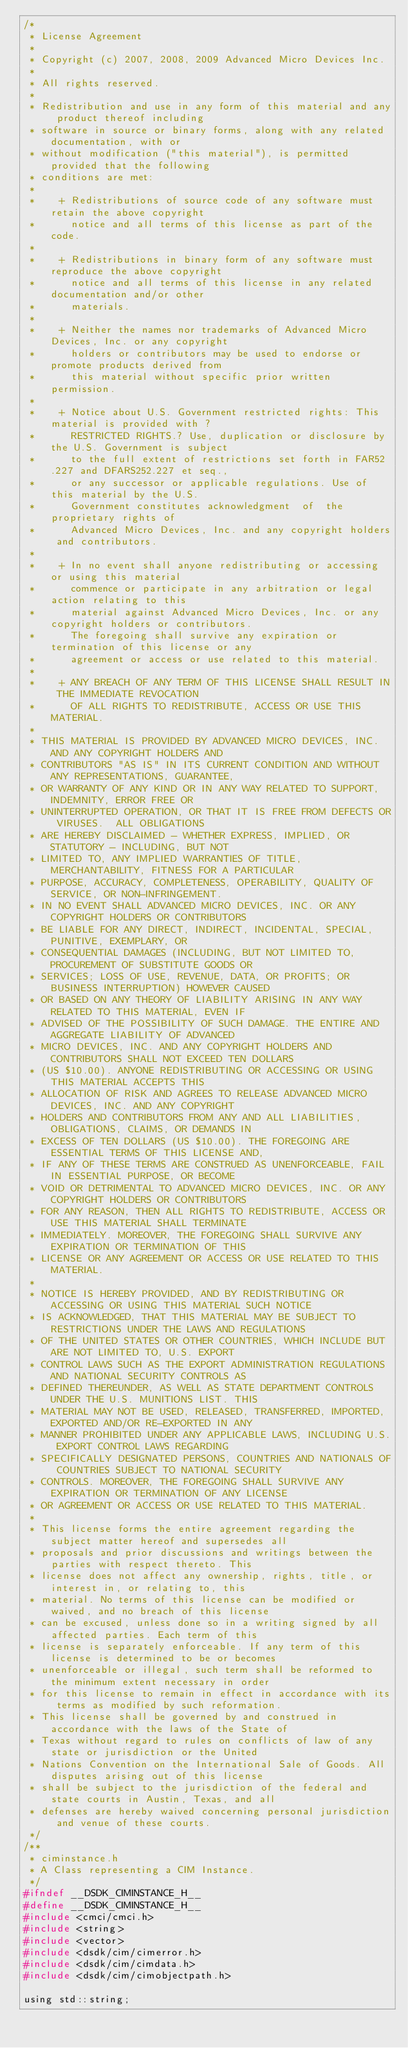Convert code to text. <code><loc_0><loc_0><loc_500><loc_500><_C_>/*
 * License Agreement 
 *
 * Copyright (c) 2007, 2008, 2009 Advanced Micro Devices Inc.
 *
 * All rights reserved.
 *
 * Redistribution and use in any form of this material and any product thereof including
 * software in source or binary forms, along with any related documentation, with or 
 * without modification ("this material"), is permitted provided that the following 
 * conditions are met:
 *
 *    + Redistributions of source code of any software must retain the above copyright 
 *      notice and all terms of this license as part of the code.
 *
 *    + Redistributions in binary form of any software must reproduce the above copyright 
 *      notice and all terms of this license in any related documentation and/or other 
 *      materials.
 *
 *    + Neither the names nor trademarks of Advanced Micro Devices, Inc. or any copyright 
 *      holders or contributors may be used to endorse or promote products derived from 
 *      this material without specific prior written permission.
 *
 *    + Notice about U.S. Government restricted rights: This material is provided with ?
 *      RESTRICTED RIGHTS.? Use, duplication or disclosure by the U.S. Government is subject 
 *      to the full extent of restrictions set forth in FAR52.227 and DFARS252.227 et seq., 
 *      or any successor or applicable regulations. Use of this material by the U.S. 
 *      Government constitutes acknowledgment  of  the  proprietary rights of 
 *      Advanced Micro Devices, Inc. and any copyright holders and contributors. 
 *
 *    + In no event shall anyone redistributing or accessing or using this material 
 *      commence or participate in any arbitration or legal action relating to this 
 *      material against Advanced Micro Devices, Inc. or any copyright holders or contributors. 
 *      The foregoing shall survive any expiration or termination of this license or any 
 *      agreement or access or use related to this material.  
 *
 *    + ANY BREACH OF ANY TERM OF THIS LICENSE SHALL RESULT IN THE IMMEDIATE REVOCATION 
 *      OF ALL RIGHTS TO REDISTRIBUTE, ACCESS OR USE THIS MATERIAL. 
 *
 * THIS MATERIAL IS PROVIDED BY ADVANCED MICRO DEVICES, INC. AND ANY COPYRIGHT HOLDERS AND 
 * CONTRIBUTORS "AS IS" IN ITS CURRENT CONDITION AND WITHOUT ANY REPRESENTATIONS, GUARANTEE, 
 * OR WARRANTY OF ANY KIND OR IN ANY WAY RELATED TO SUPPORT, INDEMNITY, ERROR FREE OR 
 * UNINTERRUPTED OPERATION, OR THAT IT IS FREE FROM DEFECTS OR VIRUSES.  ALL OBLIGATIONS 
 * ARE HEREBY DISCLAIMED - WHETHER EXPRESS, IMPLIED, OR STATUTORY - INCLUDING, BUT NOT 
 * LIMITED TO, ANY IMPLIED WARRANTIES OF TITLE, MERCHANTABILITY, FITNESS FOR A PARTICULAR 
 * PURPOSE, ACCURACY, COMPLETENESS, OPERABILITY, QUALITY OF SERVICE, OR NON-INFRINGEMENT. 
 * IN NO EVENT SHALL ADVANCED MICRO DEVICES, INC. OR ANY COPYRIGHT HOLDERS OR CONTRIBUTORS 
 * BE LIABLE FOR ANY DIRECT, INDIRECT, INCIDENTAL, SPECIAL, PUNITIVE, EXEMPLARY, OR 
 * CONSEQUENTIAL DAMAGES (INCLUDING, BUT NOT LIMITED TO, PROCUREMENT OF SUBSTITUTE GOODS OR 
 * SERVICES; LOSS OF USE, REVENUE, DATA, OR PROFITS; OR BUSINESS INTERRUPTION) HOWEVER CAUSED 
 * OR BASED ON ANY THEORY OF LIABILITY ARISING IN ANY WAY RELATED TO THIS MATERIAL, EVEN IF 
 * ADVISED OF THE POSSIBILITY OF SUCH DAMAGE. THE ENTIRE AND AGGREGATE LIABILITY OF ADVANCED 
 * MICRO DEVICES, INC. AND ANY COPYRIGHT HOLDERS AND CONTRIBUTORS SHALL NOT EXCEED TEN DOLLARS 
 * (US $10.00). ANYONE REDISTRIBUTING OR ACCESSING OR USING THIS MATERIAL ACCEPTS THIS 
 * ALLOCATION OF RISK AND AGREES TO RELEASE ADVANCED MICRO DEVICES, INC. AND ANY COPYRIGHT 
 * HOLDERS AND CONTRIBUTORS FROM ANY AND ALL LIABILITIES, OBLIGATIONS, CLAIMS, OR DEMANDS IN 
 * EXCESS OF TEN DOLLARS (US $10.00). THE FOREGOING ARE ESSENTIAL TERMS OF THIS LICENSE AND, 
 * IF ANY OF THESE TERMS ARE CONSTRUED AS UNENFORCEABLE, FAIL IN ESSENTIAL PURPOSE, OR BECOME 
 * VOID OR DETRIMENTAL TO ADVANCED MICRO DEVICES, INC. OR ANY COPYRIGHT HOLDERS OR CONTRIBUTORS 
 * FOR ANY REASON, THEN ALL RIGHTS TO REDISTRIBUTE, ACCESS OR USE THIS MATERIAL SHALL TERMINATE 
 * IMMEDIATELY. MOREOVER, THE FOREGOING SHALL SURVIVE ANY EXPIRATION OR TERMINATION OF THIS 
 * LICENSE OR ANY AGREEMENT OR ACCESS OR USE RELATED TO THIS MATERIAL. 
 *
 * NOTICE IS HEREBY PROVIDED, AND BY REDISTRIBUTING OR ACCESSING OR USING THIS MATERIAL SUCH NOTICE 
 * IS ACKNOWLEDGED, THAT THIS MATERIAL MAY BE SUBJECT TO RESTRICTIONS UNDER THE LAWS AND REGULATIONS 
 * OF THE UNITED STATES OR OTHER COUNTRIES, WHICH INCLUDE BUT ARE NOT LIMITED TO, U.S. EXPORT 
 * CONTROL LAWS SUCH AS THE EXPORT ADMINISTRATION REGULATIONS AND NATIONAL SECURITY CONTROLS AS 
 * DEFINED THEREUNDER, AS WELL AS STATE DEPARTMENT CONTROLS UNDER THE U.S. MUNITIONS LIST. THIS 
 * MATERIAL MAY NOT BE USED, RELEASED, TRANSFERRED, IMPORTED, EXPORTED AND/OR RE-EXPORTED IN ANY 
 * MANNER PROHIBITED UNDER ANY APPLICABLE LAWS, INCLUDING U.S. EXPORT CONTROL LAWS REGARDING 
 * SPECIFICALLY DESIGNATED PERSONS, COUNTRIES AND NATIONALS OF COUNTRIES SUBJECT TO NATIONAL SECURITY 
 * CONTROLS. MOREOVER, THE FOREGOING SHALL SURVIVE ANY EXPIRATION OR TERMINATION OF ANY LICENSE 
 * OR AGREEMENT OR ACCESS OR USE RELATED TO THIS MATERIAL. 
 *
 * This license forms the entire agreement regarding the subject matter hereof and supersedes all 
 * proposals and prior discussions and writings between the parties with respect thereto. This 
 * license does not affect any ownership, rights, title, or interest in, or relating to, this 
 * material. No terms of this license can be modified or waived, and no breach of this license 
 * can be excused, unless done so in a writing signed by all affected parties. Each term of this 
 * license is separately enforceable. If any term of this license is determined to be or becomes 
 * unenforceable or illegal, such term shall be reformed to the minimum extent necessary in order 
 * for this license to remain in effect in accordance with its terms as modified by such reformation. 
 * This license shall be governed by and construed in accordance with the laws of the State of 
 * Texas without regard to rules on conflicts of law of any state or jurisdiction or the United 
 * Nations Convention on the International Sale of Goods. All disputes arising out of this license 
 * shall be subject to the jurisdiction of the federal and state courts in Austin, Texas, and all 
 * defenses are hereby waived concerning personal jurisdiction and venue of these courts.
 */
/**
 * ciminstance.h
 * A Class representing a CIM Instance.
 */
#ifndef __DSDK_CIMINSTANCE_H__
#define __DSDK_CIMINSTANCE_H__
#include <cmci/cmci.h>
#include <string>
#include <vector>
#include <dsdk/cim/cimerror.h>
#include <dsdk/cim/cimdata.h>
#include <dsdk/cim/cimobjectpath.h>

using std::string;</code> 